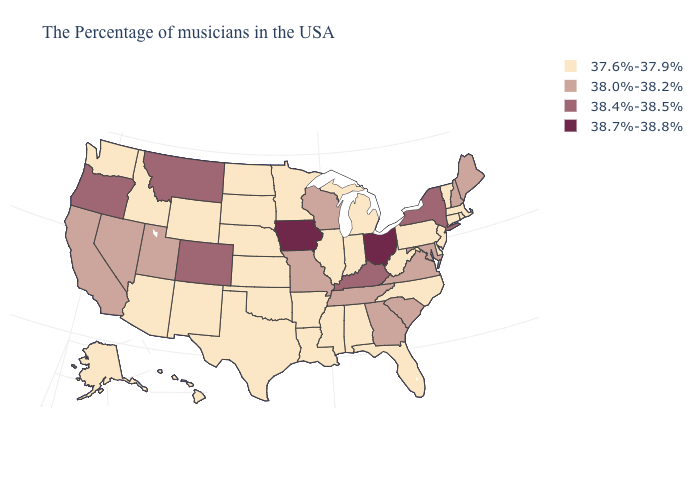Is the legend a continuous bar?
Concise answer only. No. Is the legend a continuous bar?
Concise answer only. No. Does the first symbol in the legend represent the smallest category?
Concise answer only. Yes. Name the states that have a value in the range 38.0%-38.2%?
Be succinct. Maine, New Hampshire, Maryland, Virginia, South Carolina, Georgia, Tennessee, Wisconsin, Missouri, Utah, Nevada, California. Among the states that border Kansas , which have the lowest value?
Short answer required. Nebraska, Oklahoma. Among the states that border West Virginia , which have the highest value?
Keep it brief. Ohio. Does Texas have a lower value than Ohio?
Keep it brief. Yes. What is the highest value in the USA?
Keep it brief. 38.7%-38.8%. Does North Carolina have the same value as Illinois?
Quick response, please. Yes. What is the value of Maryland?
Short answer required. 38.0%-38.2%. Name the states that have a value in the range 38.4%-38.5%?
Concise answer only. New York, Kentucky, Colorado, Montana, Oregon. What is the value of Maryland?
Give a very brief answer. 38.0%-38.2%. What is the value of South Dakota?
Concise answer only. 37.6%-37.9%. Does Utah have a lower value than Illinois?
Answer briefly. No. Which states have the lowest value in the USA?
Answer briefly. Massachusetts, Rhode Island, Vermont, Connecticut, New Jersey, Delaware, Pennsylvania, North Carolina, West Virginia, Florida, Michigan, Indiana, Alabama, Illinois, Mississippi, Louisiana, Arkansas, Minnesota, Kansas, Nebraska, Oklahoma, Texas, South Dakota, North Dakota, Wyoming, New Mexico, Arizona, Idaho, Washington, Alaska, Hawaii. 